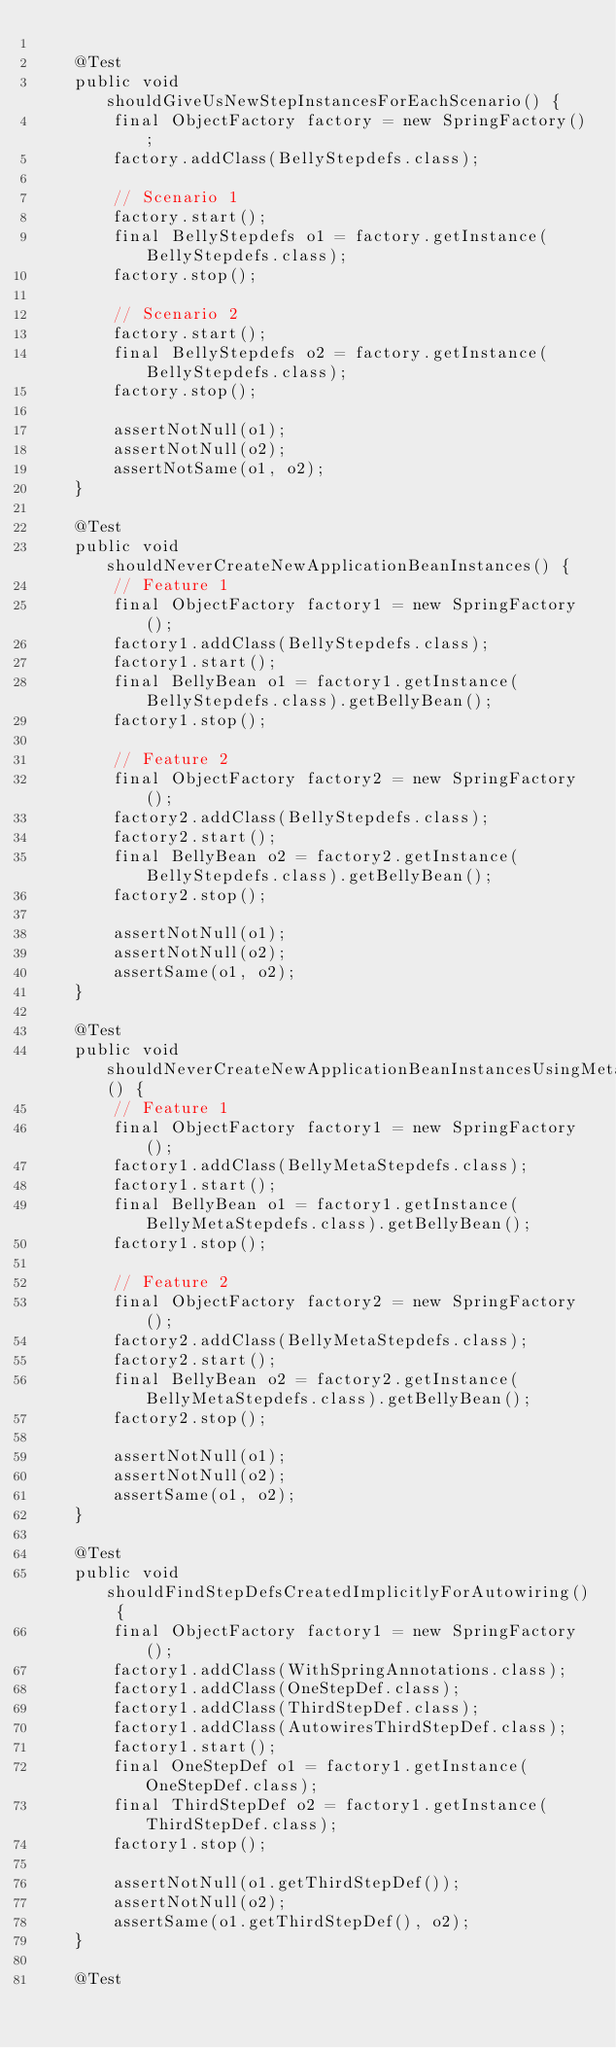Convert code to text. <code><loc_0><loc_0><loc_500><loc_500><_Java_>
    @Test
    public void shouldGiveUsNewStepInstancesForEachScenario() {
        final ObjectFactory factory = new SpringFactory();
        factory.addClass(BellyStepdefs.class);

        // Scenario 1
        factory.start();
        final BellyStepdefs o1 = factory.getInstance(BellyStepdefs.class);
        factory.stop();

        // Scenario 2
        factory.start();
        final BellyStepdefs o2 = factory.getInstance(BellyStepdefs.class);
        factory.stop();

        assertNotNull(o1);
        assertNotNull(o2);
        assertNotSame(o1, o2);
    }

    @Test
    public void shouldNeverCreateNewApplicationBeanInstances() {
        // Feature 1
        final ObjectFactory factory1 = new SpringFactory();
        factory1.addClass(BellyStepdefs.class);
        factory1.start();
        final BellyBean o1 = factory1.getInstance(BellyStepdefs.class).getBellyBean();
        factory1.stop();

        // Feature 2
        final ObjectFactory factory2 = new SpringFactory();
        factory2.addClass(BellyStepdefs.class);
        factory2.start();
        final BellyBean o2 = factory2.getInstance(BellyStepdefs.class).getBellyBean();
        factory2.stop();

        assertNotNull(o1);
        assertNotNull(o2);
        assertSame(o1, o2);
    }

    @Test
    public void shouldNeverCreateNewApplicationBeanInstancesUsingMetaConfiguration() {
        // Feature 1
        final ObjectFactory factory1 = new SpringFactory();
        factory1.addClass(BellyMetaStepdefs.class);
        factory1.start();
        final BellyBean o1 = factory1.getInstance(BellyMetaStepdefs.class).getBellyBean();
        factory1.stop();

        // Feature 2
        final ObjectFactory factory2 = new SpringFactory();
        factory2.addClass(BellyMetaStepdefs.class);
        factory2.start();
        final BellyBean o2 = factory2.getInstance(BellyMetaStepdefs.class).getBellyBean();
        factory2.stop();

        assertNotNull(o1);
        assertNotNull(o2);
        assertSame(o1, o2);
    }

    @Test
    public void shouldFindStepDefsCreatedImplicitlyForAutowiring() {
        final ObjectFactory factory1 = new SpringFactory();
        factory1.addClass(WithSpringAnnotations.class);
        factory1.addClass(OneStepDef.class);
        factory1.addClass(ThirdStepDef.class);
        factory1.addClass(AutowiresThirdStepDef.class);
        factory1.start();
        final OneStepDef o1 = factory1.getInstance(OneStepDef.class);
        final ThirdStepDef o2 = factory1.getInstance(ThirdStepDef.class);
        factory1.stop();

        assertNotNull(o1.getThirdStepDef());
        assertNotNull(o2);
        assertSame(o1.getThirdStepDef(), o2);
    }

    @Test</code> 